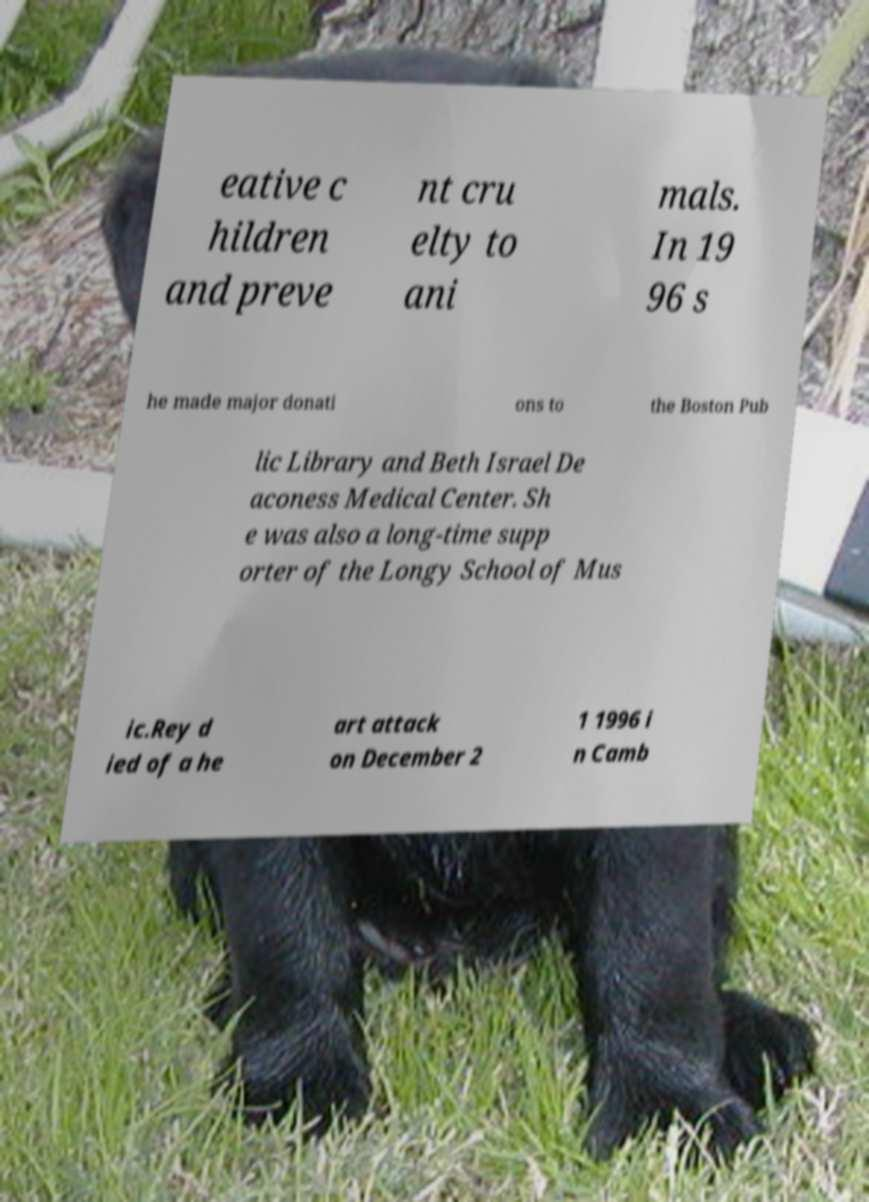Please identify and transcribe the text found in this image. eative c hildren and preve nt cru elty to ani mals. In 19 96 s he made major donati ons to the Boston Pub lic Library and Beth Israel De aconess Medical Center. Sh e was also a long-time supp orter of the Longy School of Mus ic.Rey d ied of a he art attack on December 2 1 1996 i n Camb 